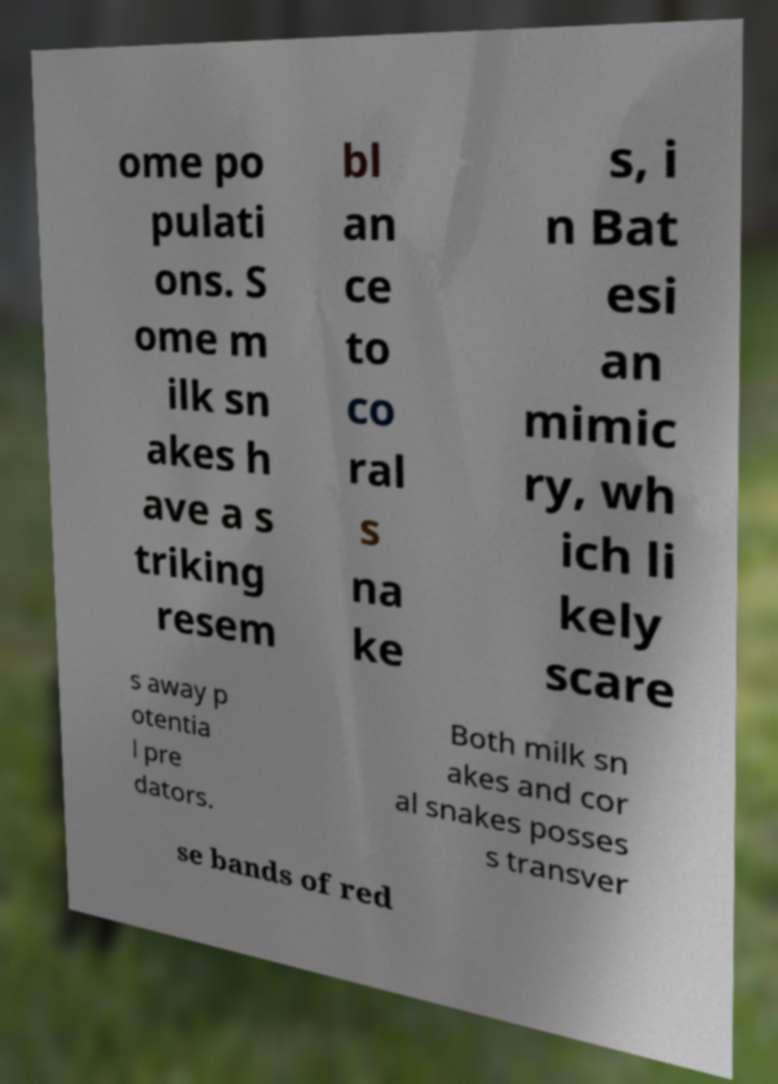Can you read and provide the text displayed in the image?This photo seems to have some interesting text. Can you extract and type it out for me? ome po pulati ons. S ome m ilk sn akes h ave a s triking resem bl an ce to co ral s na ke s, i n Bat esi an mimic ry, wh ich li kely scare s away p otentia l pre dators. Both milk sn akes and cor al snakes posses s transver se bands of red 